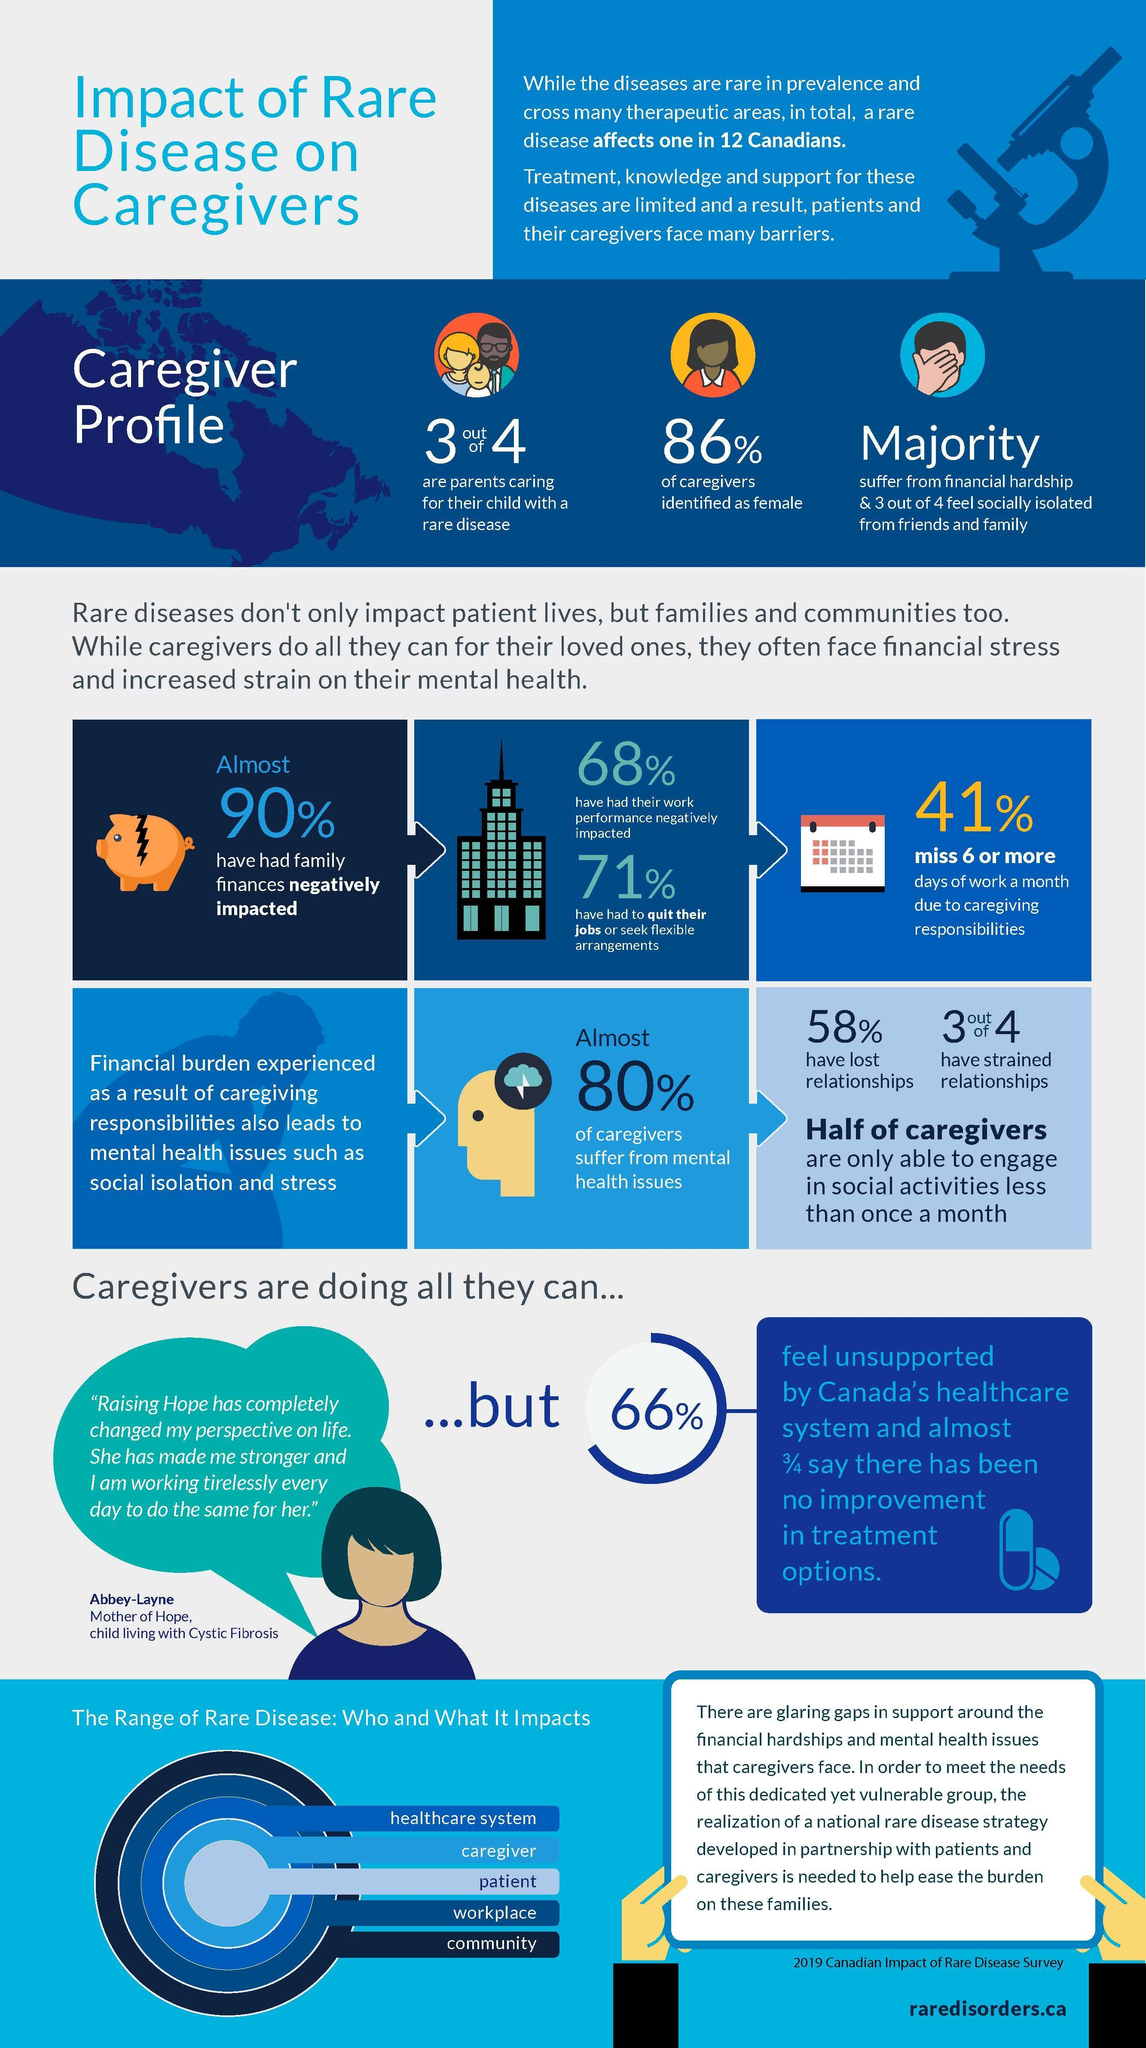What percentage of caregivers feel socially isolated from friends and family?
Answer the question with a short phrase. 75% What percentage of caregivers have strained relationships? 75% What percentage of caregivers are only able to engage in social activities less than once a month? 50% What percentage of parents are caring for their child with a rare disease? 75% 